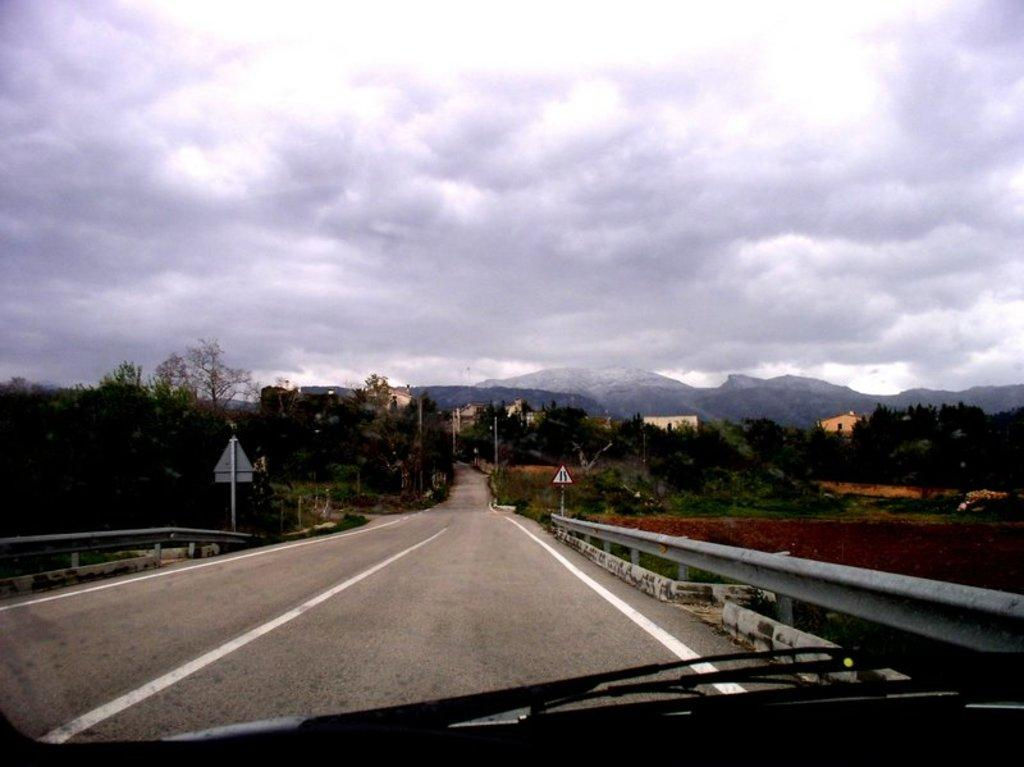What can be seen in the sky in the image? The sky with clouds is visible in the image. What type of natural features are present in the image? There are hills in the image. What type of man-made structures are present in the image? There are buildings in the image. What type of vegetation is present in the image? Trees are present in the image. What type of street furniture is visible in the image? Street poles are visible in the image. What type of signage is present in the image? Sign boards are present in the image. What type of barriers are visible in the image? Barriers are visible in the image. What type of surface is visible in the image? The ground is visible in the image. What type of transportation infrastructure is visible in the image? A road is visible in the image. How many lizards can be seen crawling on the sign boards in the image? There are no lizards present in the image; it only features a sky with clouds, hills, buildings, trees, street poles, sign boards, barriers, ground, and a road. What is the speed limit for cars on the road in the image? There is no information about a speed limit or cars present in the image. 